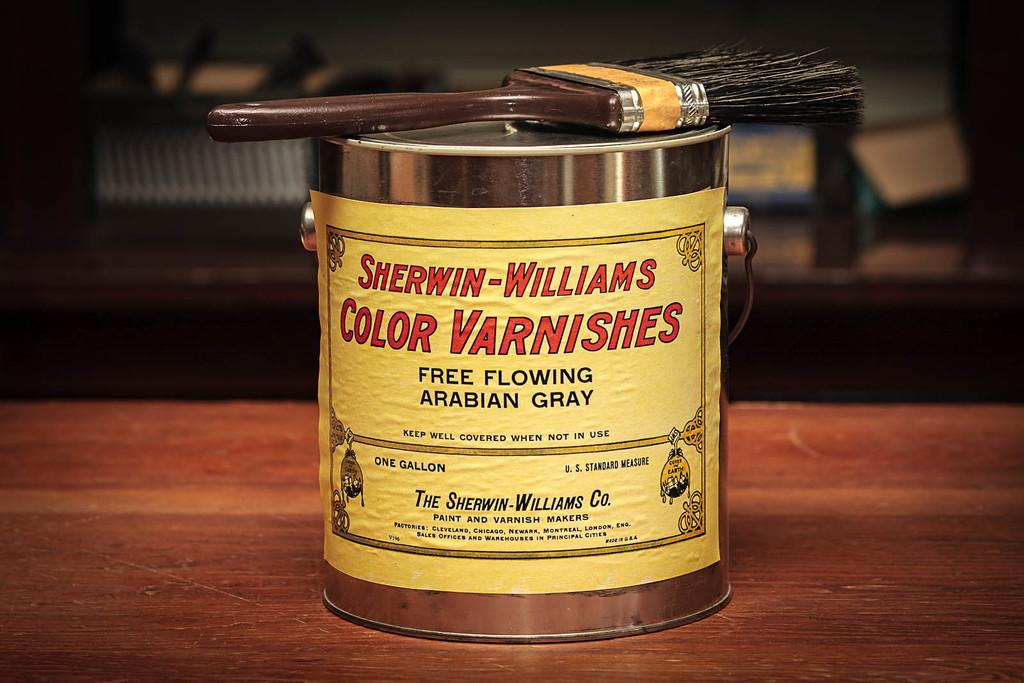Provide a one-sentence caption for the provided image. a can that says sherwin williams on the front. 